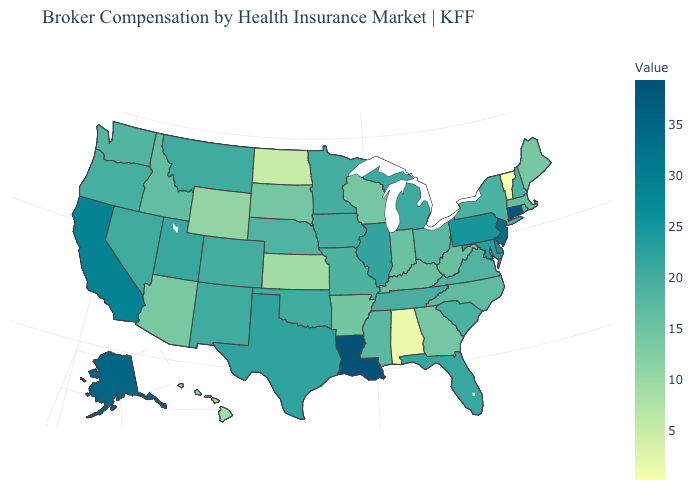Among the states that border West Virginia , does Kentucky have the lowest value?
Be succinct. Yes. Among the states that border Tennessee , does Georgia have the lowest value?
Give a very brief answer. No. Which states have the lowest value in the Northeast?
Short answer required. Vermont. Is the legend a continuous bar?
Be succinct. Yes. Does Indiana have a higher value than Alabama?
Write a very short answer. Yes. Does Hawaii have the lowest value in the West?
Quick response, please. Yes. Which states hav the highest value in the West?
Keep it brief. Alaska. Does Vermont have the lowest value in the USA?
Quick response, please. Yes. Does Ohio have the lowest value in the MidWest?
Keep it brief. No. 